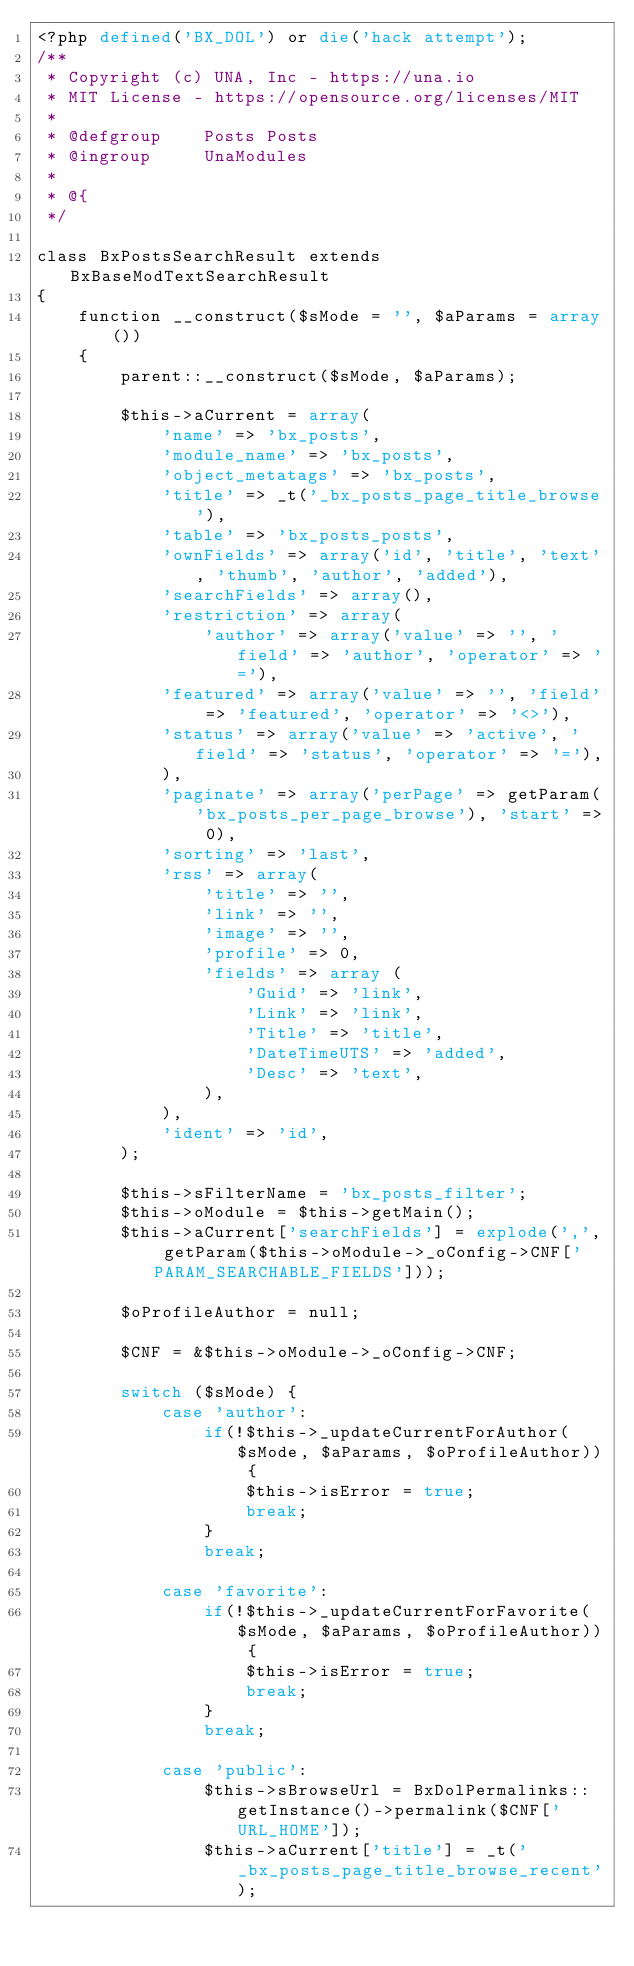Convert code to text. <code><loc_0><loc_0><loc_500><loc_500><_PHP_><?php defined('BX_DOL') or die('hack attempt');
/**
 * Copyright (c) UNA, Inc - https://una.io
 * MIT License - https://opensource.org/licenses/MIT
 *
 * @defgroup    Posts Posts
 * @ingroup     UnaModules
 *
 * @{
 */

class BxPostsSearchResult extends BxBaseModTextSearchResult
{
    function __construct($sMode = '', $aParams = array())
    {
        parent::__construct($sMode, $aParams);

        $this->aCurrent = array(
            'name' => 'bx_posts',
            'module_name' => 'bx_posts',
            'object_metatags' => 'bx_posts',
            'title' => _t('_bx_posts_page_title_browse'),
            'table' => 'bx_posts_posts',
            'ownFields' => array('id', 'title', 'text', 'thumb', 'author', 'added'),
            'searchFields' => array(),
            'restriction' => array(
                'author' => array('value' => '', 'field' => 'author', 'operator' => '='),
        		'featured' => array('value' => '', 'field' => 'featured', 'operator' => '<>'),
        		'status' => array('value' => 'active', 'field' => 'status', 'operator' => '='),
            ),
            'paginate' => array('perPage' => getParam('bx_posts_per_page_browse'), 'start' => 0),
            'sorting' => 'last',
            'rss' => array(
                'title' => '',
                'link' => '',
                'image' => '',
                'profile' => 0,
                'fields' => array (
                    'Guid' => 'link',
                    'Link' => 'link',
                    'Title' => 'title',
                    'DateTimeUTS' => 'added',
                    'Desc' => 'text',
                ),
            ),
            'ident' => 'id',
        );

        $this->sFilterName = 'bx_posts_filter';
        $this->oModule = $this->getMain();
        $this->aCurrent['searchFields'] = explode(',', getParam($this->oModule->_oConfig->CNF['PARAM_SEARCHABLE_FIELDS']));

        $oProfileAuthor = null;

        $CNF = &$this->oModule->_oConfig->CNF;

        switch ($sMode) {
            case 'author':
                if(!$this->_updateCurrentForAuthor($sMode, $aParams, $oProfileAuthor)) {
                    $this->isError = true;
                    break;
                }
                break;

            case 'favorite':
                if(!$this->_updateCurrentForFavorite($sMode, $aParams, $oProfileAuthor)) {
                    $this->isError = true;
                    break;
                }
                break;

            case 'public':
                $this->sBrowseUrl = BxDolPermalinks::getInstance()->permalink($CNF['URL_HOME']);
                $this->aCurrent['title'] = _t('_bx_posts_page_title_browse_recent');</code> 